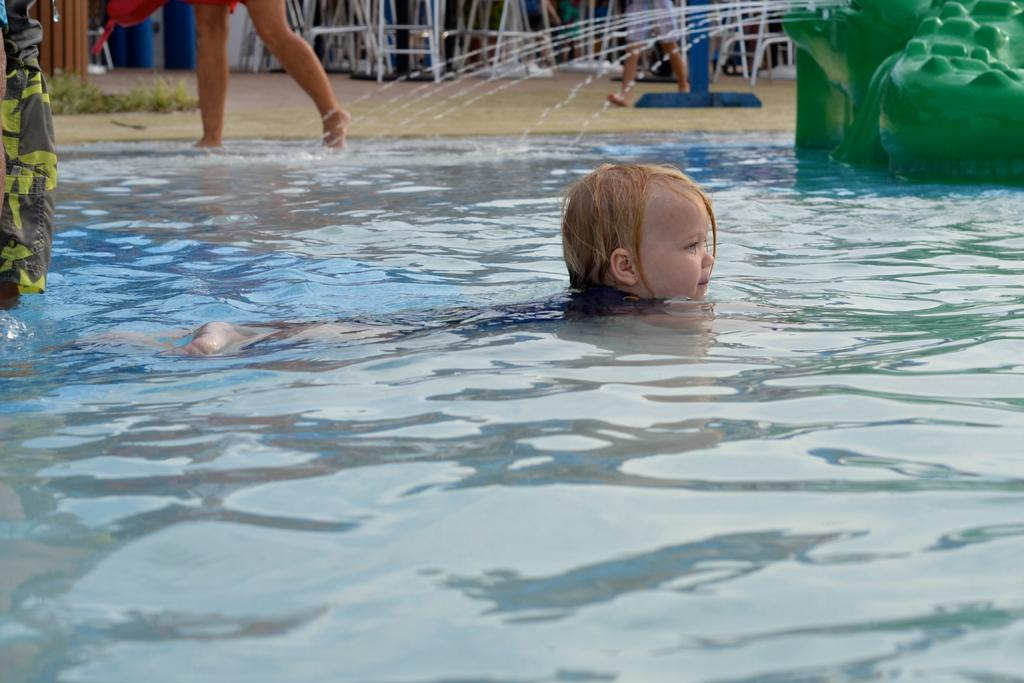What can be seen in the image? There is water visible in the image, along with a person and other objects. Can you describe the person in the image? There is a person in the image, but their appearance or actions are not specified. What is visible in the background of the image? In the background of the image, there is grass, other objects, and persons. How many persons are visible in the background? There are persons in the background of the image, but the exact number is not specified. What type of drum is being played by the person in the image? There is no drum present in the image; the person's actions are not specified. What color are the trousers worn by the person in the image? The person's clothing is not specified in the image. 